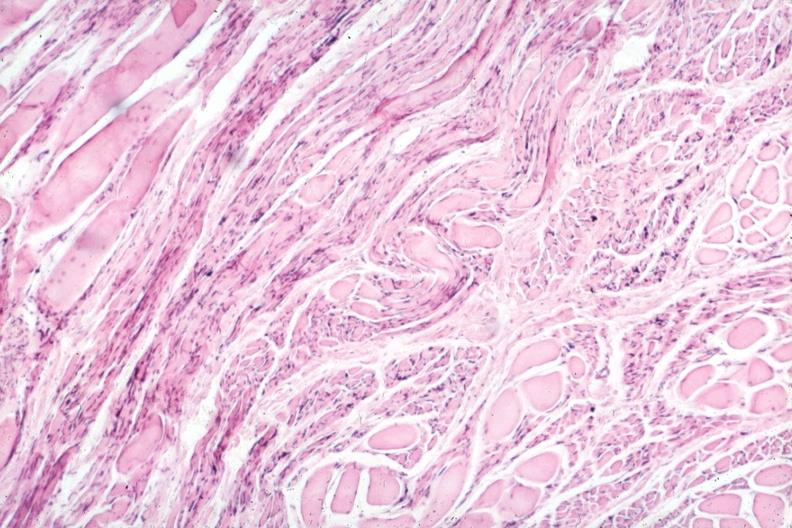s muscle present?
Answer the question using a single word or phrase. Yes 